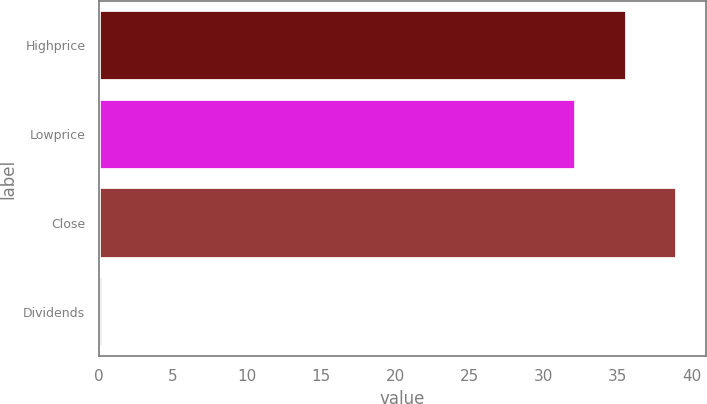<chart> <loc_0><loc_0><loc_500><loc_500><bar_chart><fcel>Highprice<fcel>Lowprice<fcel>Close<fcel>Dividends<nl><fcel>35.59<fcel>32.18<fcel>39.01<fcel>0.28<nl></chart> 